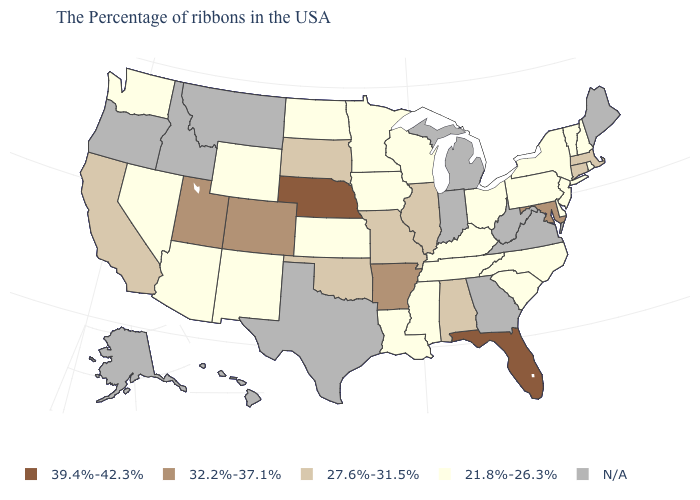Which states hav the highest value in the West?
Quick response, please. Colorado, Utah. Name the states that have a value in the range 27.6%-31.5%?
Keep it brief. Massachusetts, Connecticut, Alabama, Illinois, Missouri, Oklahoma, South Dakota, California. What is the highest value in the USA?
Short answer required. 39.4%-42.3%. What is the value of Connecticut?
Concise answer only. 27.6%-31.5%. Among the states that border Colorado , does Nebraska have the highest value?
Be succinct. Yes. Name the states that have a value in the range 32.2%-37.1%?
Give a very brief answer. Maryland, Arkansas, Colorado, Utah. What is the highest value in the MidWest ?
Keep it brief. 39.4%-42.3%. Name the states that have a value in the range 39.4%-42.3%?
Write a very short answer. Florida, Nebraska. Name the states that have a value in the range 32.2%-37.1%?
Write a very short answer. Maryland, Arkansas, Colorado, Utah. Does the first symbol in the legend represent the smallest category?
Keep it brief. No. How many symbols are there in the legend?
Concise answer only. 5. Name the states that have a value in the range 27.6%-31.5%?
Quick response, please. Massachusetts, Connecticut, Alabama, Illinois, Missouri, Oklahoma, South Dakota, California. What is the value of Massachusetts?
Short answer required. 27.6%-31.5%. What is the lowest value in states that border Vermont?
Be succinct. 21.8%-26.3%. Does Louisiana have the highest value in the South?
Answer briefly. No. 